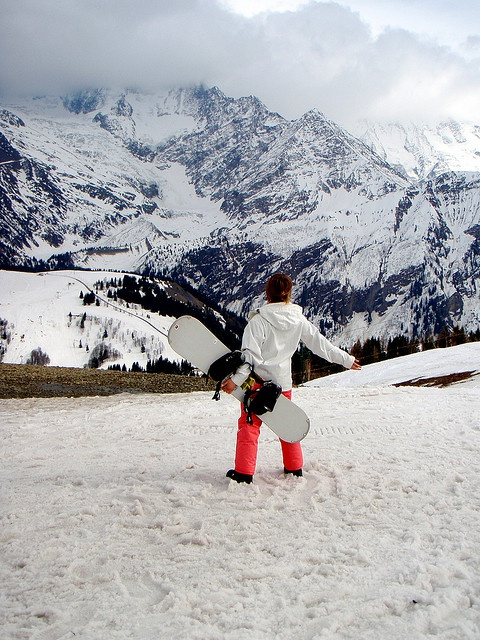Describe the objects in this image and their specific colors. I can see people in darkgray, lightgray, black, and brown tones and snowboard in darkgray, black, gray, and maroon tones in this image. 